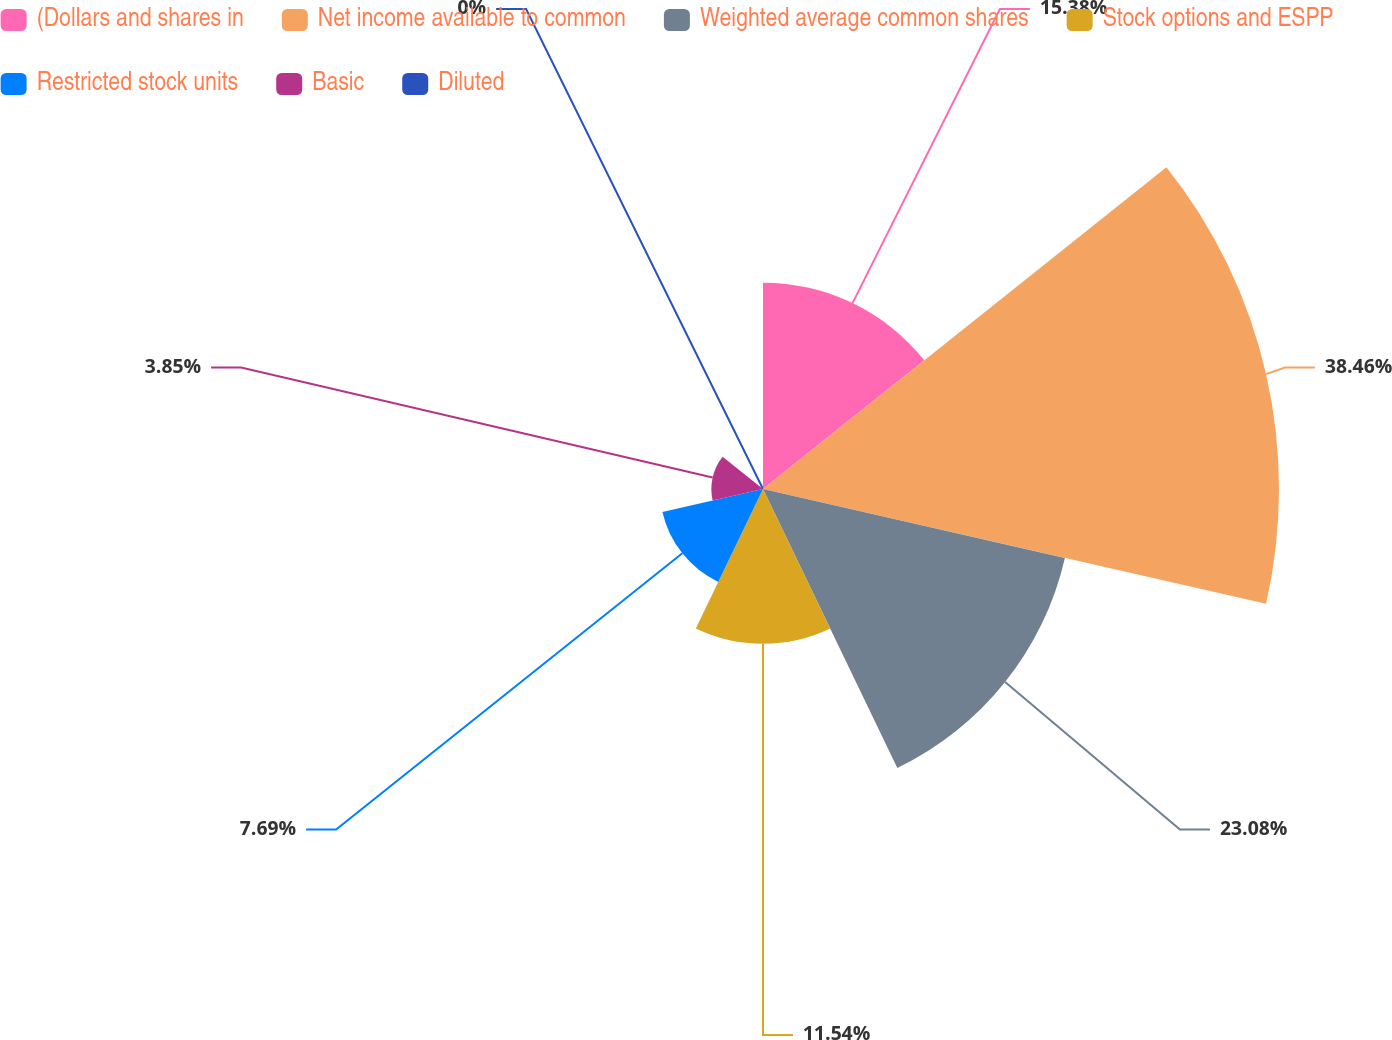Convert chart. <chart><loc_0><loc_0><loc_500><loc_500><pie_chart><fcel>(Dollars and shares in<fcel>Net income available to common<fcel>Weighted average common shares<fcel>Stock options and ESPP<fcel>Restricted stock units<fcel>Basic<fcel>Diluted<nl><fcel>15.38%<fcel>38.46%<fcel>23.08%<fcel>11.54%<fcel>7.69%<fcel>3.85%<fcel>0.0%<nl></chart> 